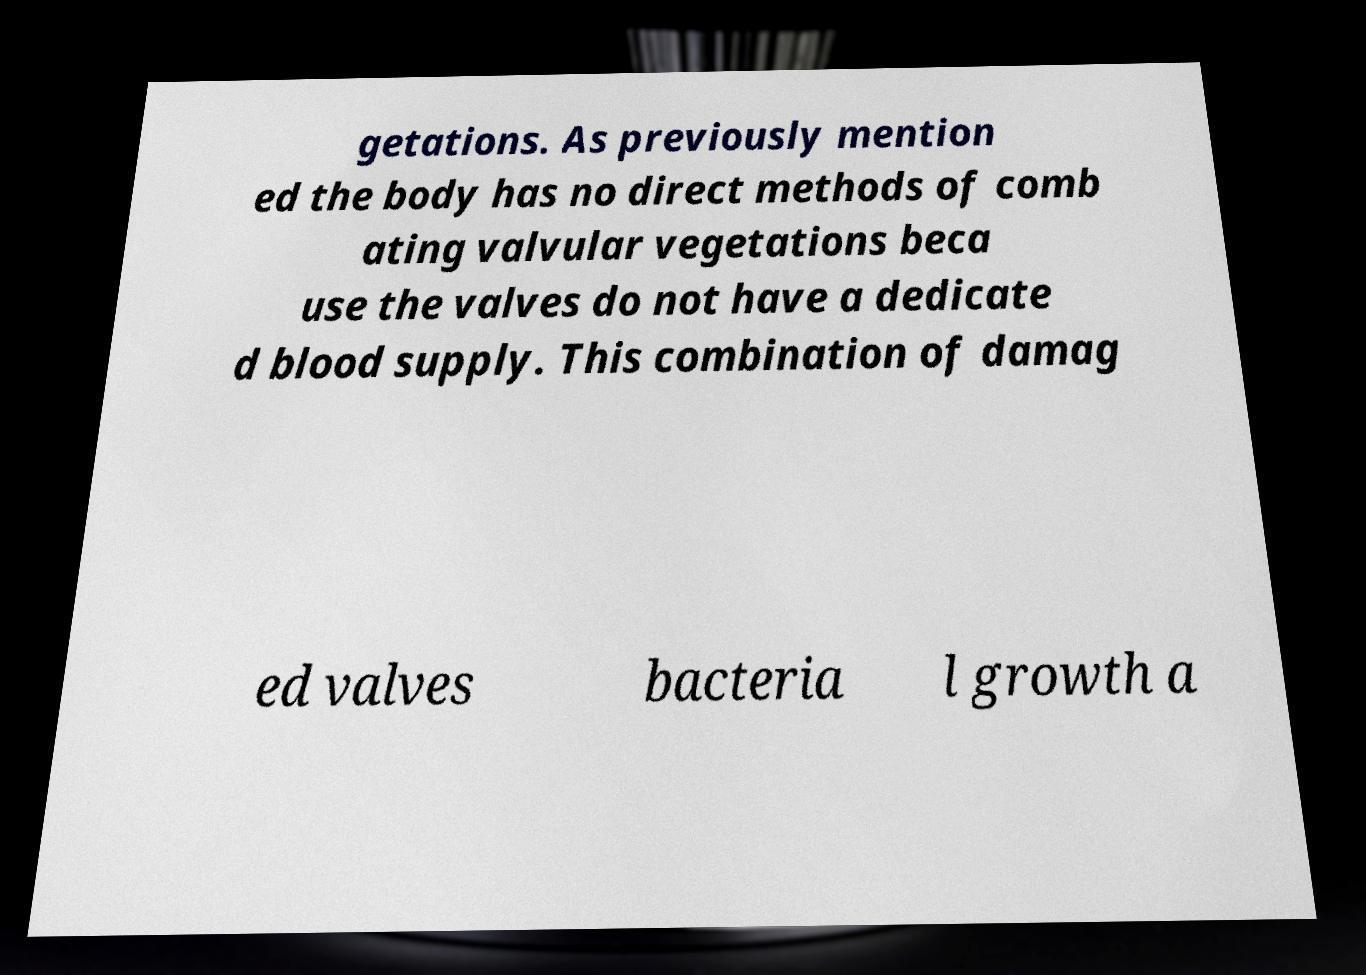I need the written content from this picture converted into text. Can you do that? getations. As previously mention ed the body has no direct methods of comb ating valvular vegetations beca use the valves do not have a dedicate d blood supply. This combination of damag ed valves bacteria l growth a 